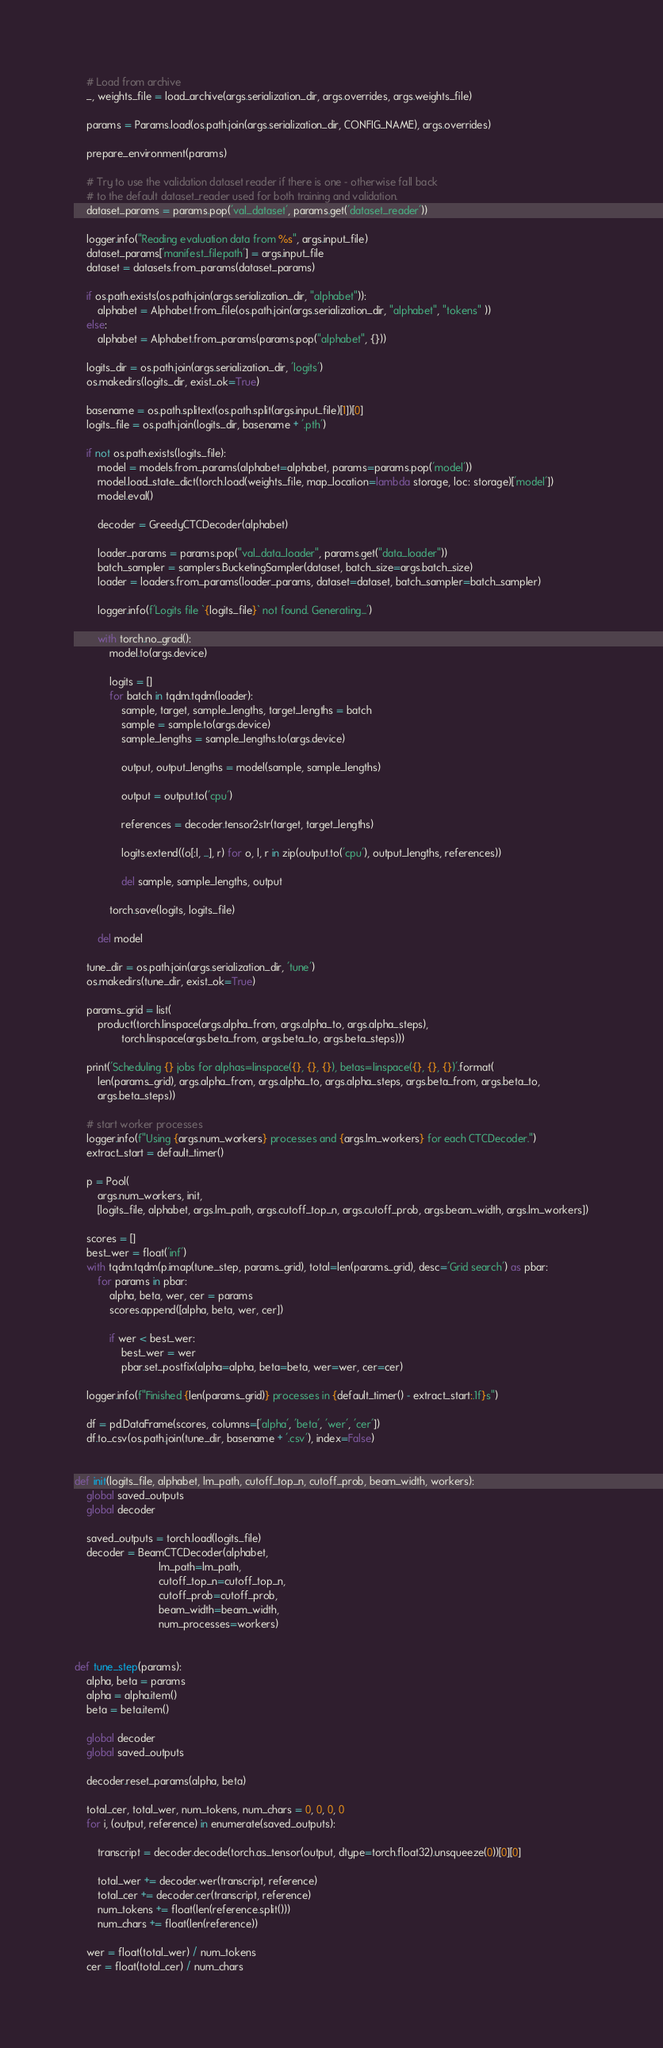Convert code to text. <code><loc_0><loc_0><loc_500><loc_500><_Python_>    # Load from archive
    _, weights_file = load_archive(args.serialization_dir, args.overrides, args.weights_file)

    params = Params.load(os.path.join(args.serialization_dir, CONFIG_NAME), args.overrides)

    prepare_environment(params)

    # Try to use the validation dataset reader if there is one - otherwise fall back
    # to the default dataset_reader used for both training and validation.
    dataset_params = params.pop('val_dataset', params.get('dataset_reader'))

    logger.info("Reading evaluation data from %s", args.input_file)
    dataset_params['manifest_filepath'] = args.input_file
    dataset = datasets.from_params(dataset_params)

    if os.path.exists(os.path.join(args.serialization_dir, "alphabet")):
        alphabet = Alphabet.from_file(os.path.join(args.serialization_dir, "alphabet", "tokens" ))
    else:
        alphabet = Alphabet.from_params(params.pop("alphabet", {}))

    logits_dir = os.path.join(args.serialization_dir, 'logits')
    os.makedirs(logits_dir, exist_ok=True)

    basename = os.path.splitext(os.path.split(args.input_file)[1])[0]
    logits_file = os.path.join(logits_dir, basename + '.pth')

    if not os.path.exists(logits_file):
        model = models.from_params(alphabet=alphabet, params=params.pop('model'))
        model.load_state_dict(torch.load(weights_file, map_location=lambda storage, loc: storage)['model'])
        model.eval()

        decoder = GreedyCTCDecoder(alphabet)

        loader_params = params.pop("val_data_loader", params.get("data_loader"))
        batch_sampler = samplers.BucketingSampler(dataset, batch_size=args.batch_size)
        loader = loaders.from_params(loader_params, dataset=dataset, batch_sampler=batch_sampler)

        logger.info(f'Logits file `{logits_file}` not found. Generating...')

        with torch.no_grad():
            model.to(args.device)

            logits = []
            for batch in tqdm.tqdm(loader):
                sample, target, sample_lengths, target_lengths = batch
                sample = sample.to(args.device)
                sample_lengths = sample_lengths.to(args.device)

                output, output_lengths = model(sample, sample_lengths)

                output = output.to('cpu')

                references = decoder.tensor2str(target, target_lengths)

                logits.extend((o[:l, ...], r) for o, l, r in zip(output.to('cpu'), output_lengths, references))

                del sample, sample_lengths, output

            torch.save(logits, logits_file)

        del model

    tune_dir = os.path.join(args.serialization_dir, 'tune')
    os.makedirs(tune_dir, exist_ok=True)

    params_grid = list(
        product(torch.linspace(args.alpha_from, args.alpha_to, args.alpha_steps),
                torch.linspace(args.beta_from, args.beta_to, args.beta_steps)))

    print('Scheduling {} jobs for alphas=linspace({}, {}, {}), betas=linspace({}, {}, {})'.format(
        len(params_grid), args.alpha_from, args.alpha_to, args.alpha_steps, args.beta_from, args.beta_to,
        args.beta_steps))

    # start worker processes
    logger.info(f"Using {args.num_workers} processes and {args.lm_workers} for each CTCDecoder.")
    extract_start = default_timer()

    p = Pool(
        args.num_workers, init,
        [logits_file, alphabet, args.lm_path, args.cutoff_top_n, args.cutoff_prob, args.beam_width, args.lm_workers])

    scores = []
    best_wer = float('inf')
    with tqdm.tqdm(p.imap(tune_step, params_grid), total=len(params_grid), desc='Grid search') as pbar:
        for params in pbar:
            alpha, beta, wer, cer = params
            scores.append([alpha, beta, wer, cer])

            if wer < best_wer:
                best_wer = wer
                pbar.set_postfix(alpha=alpha, beta=beta, wer=wer, cer=cer)

    logger.info(f"Finished {len(params_grid)} processes in {default_timer() - extract_start:.1f}s")

    df = pd.DataFrame(scores, columns=['alpha', 'beta', 'wer', 'cer'])
    df.to_csv(os.path.join(tune_dir, basename + '.csv'), index=False)


def init(logits_file, alphabet, lm_path, cutoff_top_n, cutoff_prob, beam_width, workers):
    global saved_outputs
    global decoder

    saved_outputs = torch.load(logits_file)
    decoder = BeamCTCDecoder(alphabet,
                             lm_path=lm_path,
                             cutoff_top_n=cutoff_top_n,
                             cutoff_prob=cutoff_prob,
                             beam_width=beam_width,
                             num_processes=workers)


def tune_step(params):
    alpha, beta = params
    alpha = alpha.item()
    beta = beta.item()

    global decoder
    global saved_outputs

    decoder.reset_params(alpha, beta)

    total_cer, total_wer, num_tokens, num_chars = 0, 0, 0, 0
    for i, (output, reference) in enumerate(saved_outputs):

        transcript = decoder.decode(torch.as_tensor(output, dtype=torch.float32).unsqueeze(0))[0][0]

        total_wer += decoder.wer(transcript, reference)
        total_cer += decoder.cer(transcript, reference)
        num_tokens += float(len(reference.split()))
        num_chars += float(len(reference))

    wer = float(total_wer) / num_tokens
    cer = float(total_cer) / num_chars
</code> 